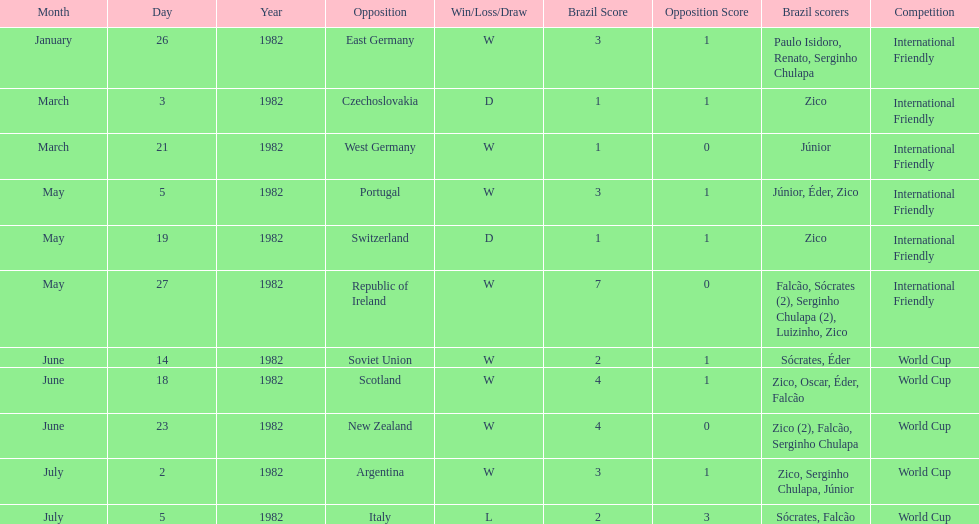How many times did brazil play west germany during the 1982 season? 1. 